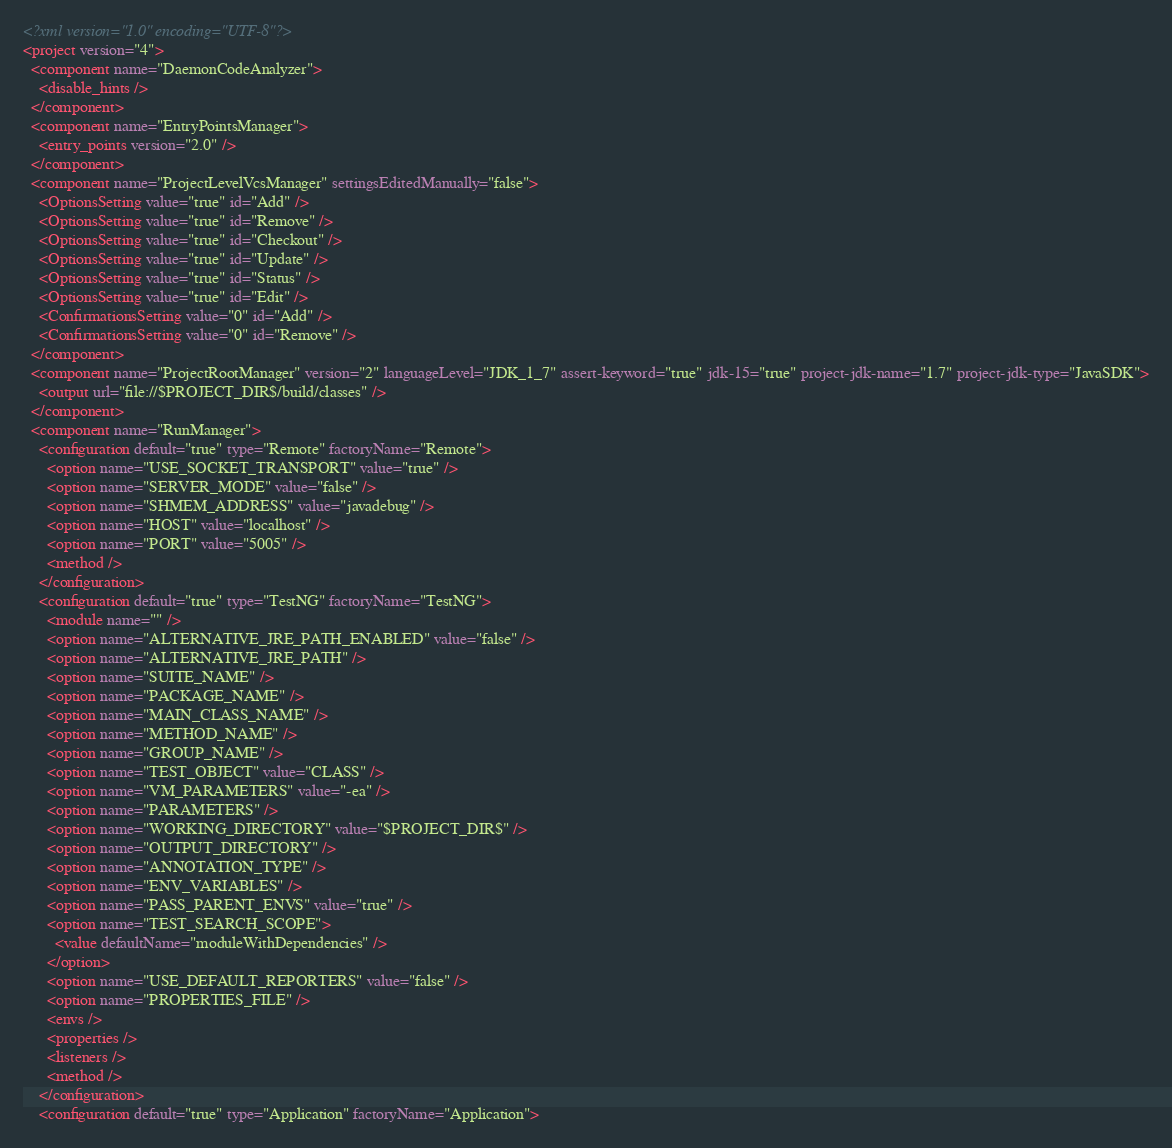Convert code to text. <code><loc_0><loc_0><loc_500><loc_500><_XML_><?xml version="1.0" encoding="UTF-8"?>
<project version="4">
  <component name="DaemonCodeAnalyzer">
    <disable_hints />
  </component>
  <component name="EntryPointsManager">
    <entry_points version="2.0" />
  </component>
  <component name="ProjectLevelVcsManager" settingsEditedManually="false">
    <OptionsSetting value="true" id="Add" />
    <OptionsSetting value="true" id="Remove" />
    <OptionsSetting value="true" id="Checkout" />
    <OptionsSetting value="true" id="Update" />
    <OptionsSetting value="true" id="Status" />
    <OptionsSetting value="true" id="Edit" />
    <ConfirmationsSetting value="0" id="Add" />
    <ConfirmationsSetting value="0" id="Remove" />
  </component>
  <component name="ProjectRootManager" version="2" languageLevel="JDK_1_7" assert-keyword="true" jdk-15="true" project-jdk-name="1.7" project-jdk-type="JavaSDK">
    <output url="file://$PROJECT_DIR$/build/classes" />
  </component>
  <component name="RunManager">
    <configuration default="true" type="Remote" factoryName="Remote">
      <option name="USE_SOCKET_TRANSPORT" value="true" />
      <option name="SERVER_MODE" value="false" />
      <option name="SHMEM_ADDRESS" value="javadebug" />
      <option name="HOST" value="localhost" />
      <option name="PORT" value="5005" />
      <method />
    </configuration>
    <configuration default="true" type="TestNG" factoryName="TestNG">
      <module name="" />
      <option name="ALTERNATIVE_JRE_PATH_ENABLED" value="false" />
      <option name="ALTERNATIVE_JRE_PATH" />
      <option name="SUITE_NAME" />
      <option name="PACKAGE_NAME" />
      <option name="MAIN_CLASS_NAME" />
      <option name="METHOD_NAME" />
      <option name="GROUP_NAME" />
      <option name="TEST_OBJECT" value="CLASS" />
      <option name="VM_PARAMETERS" value="-ea" />
      <option name="PARAMETERS" />
      <option name="WORKING_DIRECTORY" value="$PROJECT_DIR$" />
      <option name="OUTPUT_DIRECTORY" />
      <option name="ANNOTATION_TYPE" />
      <option name="ENV_VARIABLES" />
      <option name="PASS_PARENT_ENVS" value="true" />
      <option name="TEST_SEARCH_SCOPE">
        <value defaultName="moduleWithDependencies" />
      </option>
      <option name="USE_DEFAULT_REPORTERS" value="false" />
      <option name="PROPERTIES_FILE" />
      <envs />
      <properties />
      <listeners />
      <method />
    </configuration>
    <configuration default="true" type="Application" factoryName="Application"></code> 